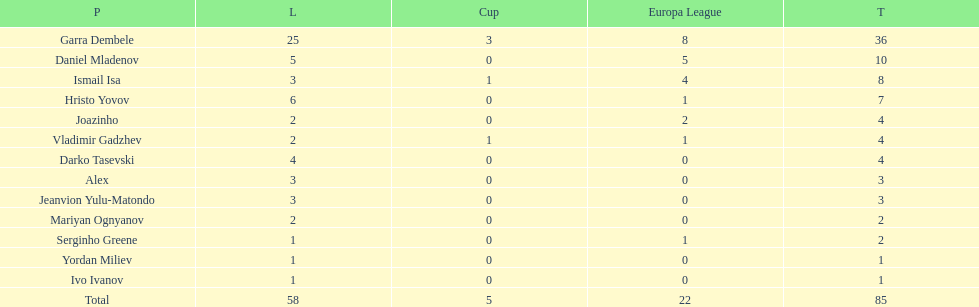How many players did not score a goal in cup play? 10. 